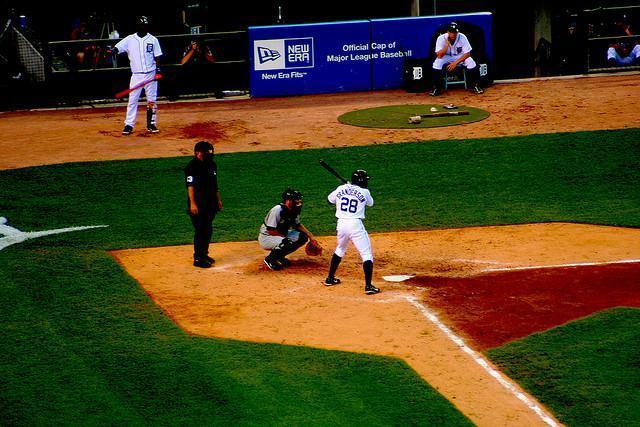How many people are in the photo?
Give a very brief answer. 4. How many elephant are facing the right side of the image?
Give a very brief answer. 0. 